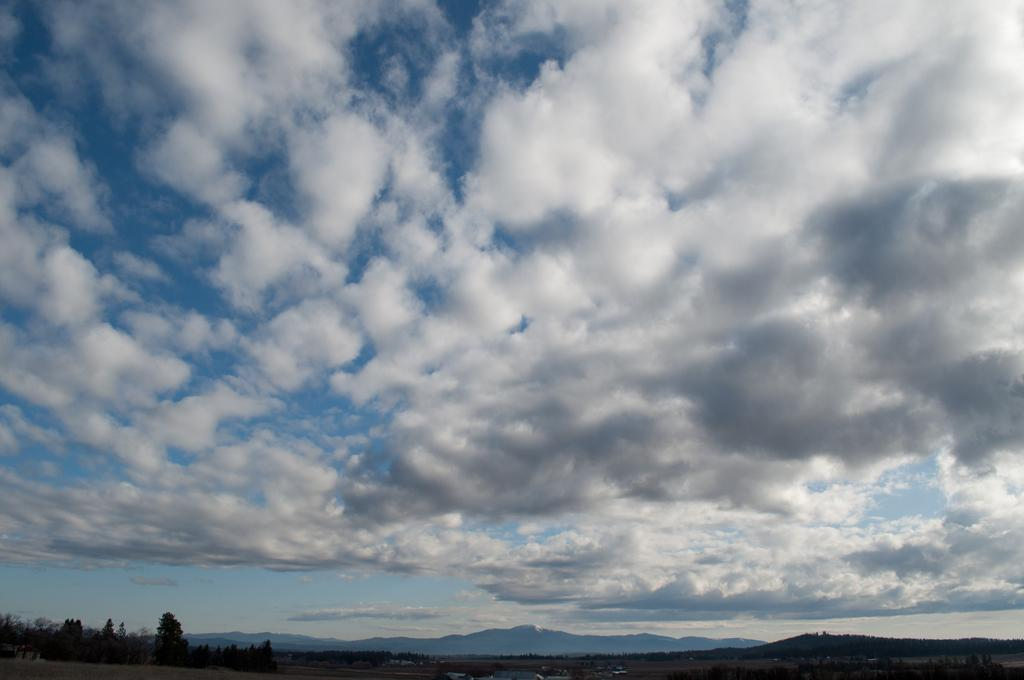What is located at the bottom of the image? There are trees, water, and mountains at the bottom of the image. What can be seen in the background of the image? The sky is visible in the background of the image. What might be the location of the image based on the visible features? The image may have been taken near the mountains. What type of bedroom can be seen in the image? There is no bedroom present in the image; it features trees, water, mountains, and the sky. What is the expansion rate of the mountains in the image? The image does not provide information about the expansion rate of the mountains. 